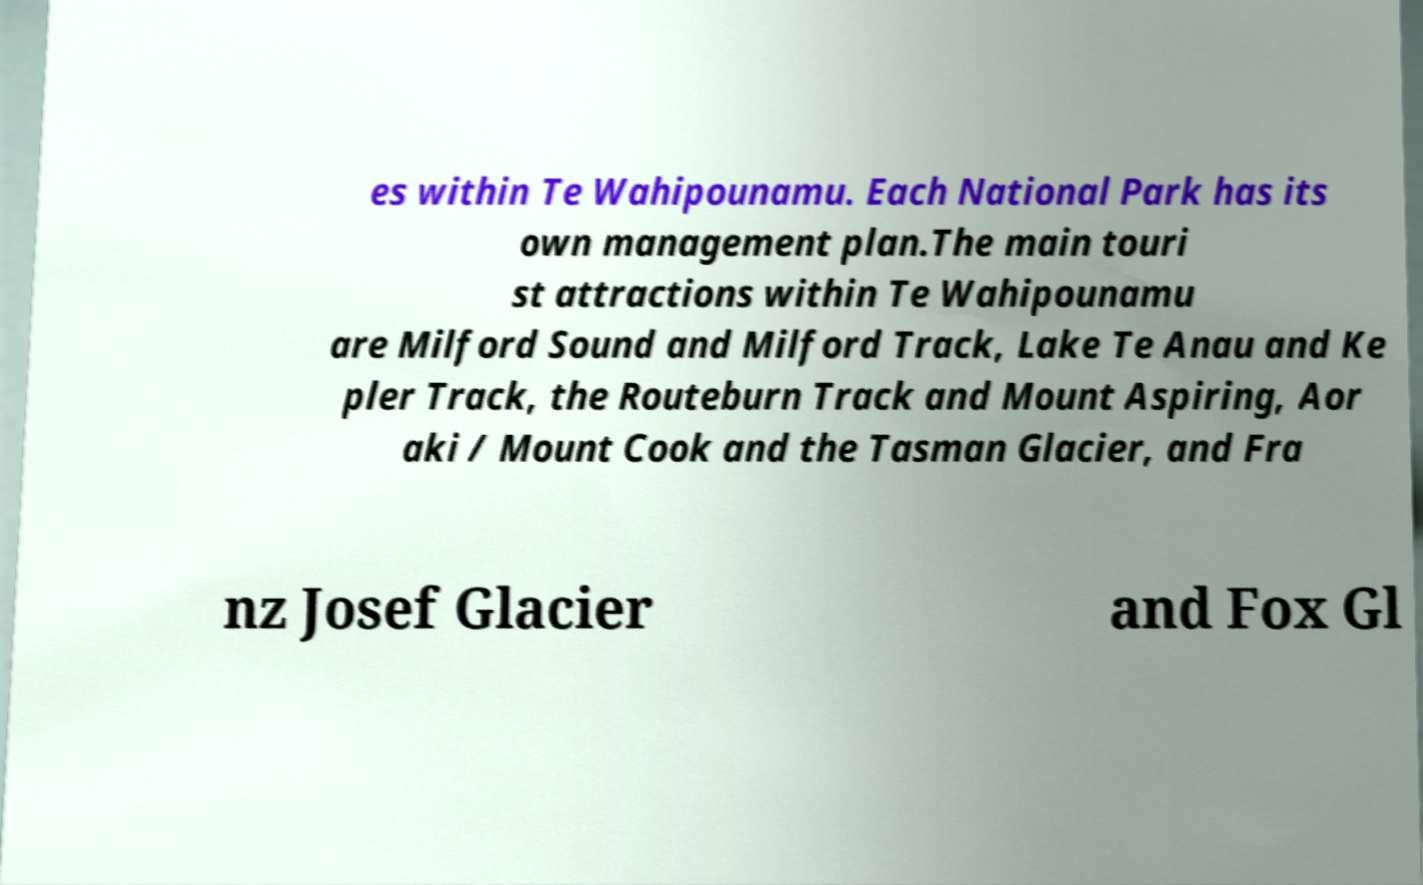There's text embedded in this image that I need extracted. Can you transcribe it verbatim? es within Te Wahipounamu. Each National Park has its own management plan.The main touri st attractions within Te Wahipounamu are Milford Sound and Milford Track, Lake Te Anau and Ke pler Track, the Routeburn Track and Mount Aspiring, Aor aki / Mount Cook and the Tasman Glacier, and Fra nz Josef Glacier and Fox Gl 